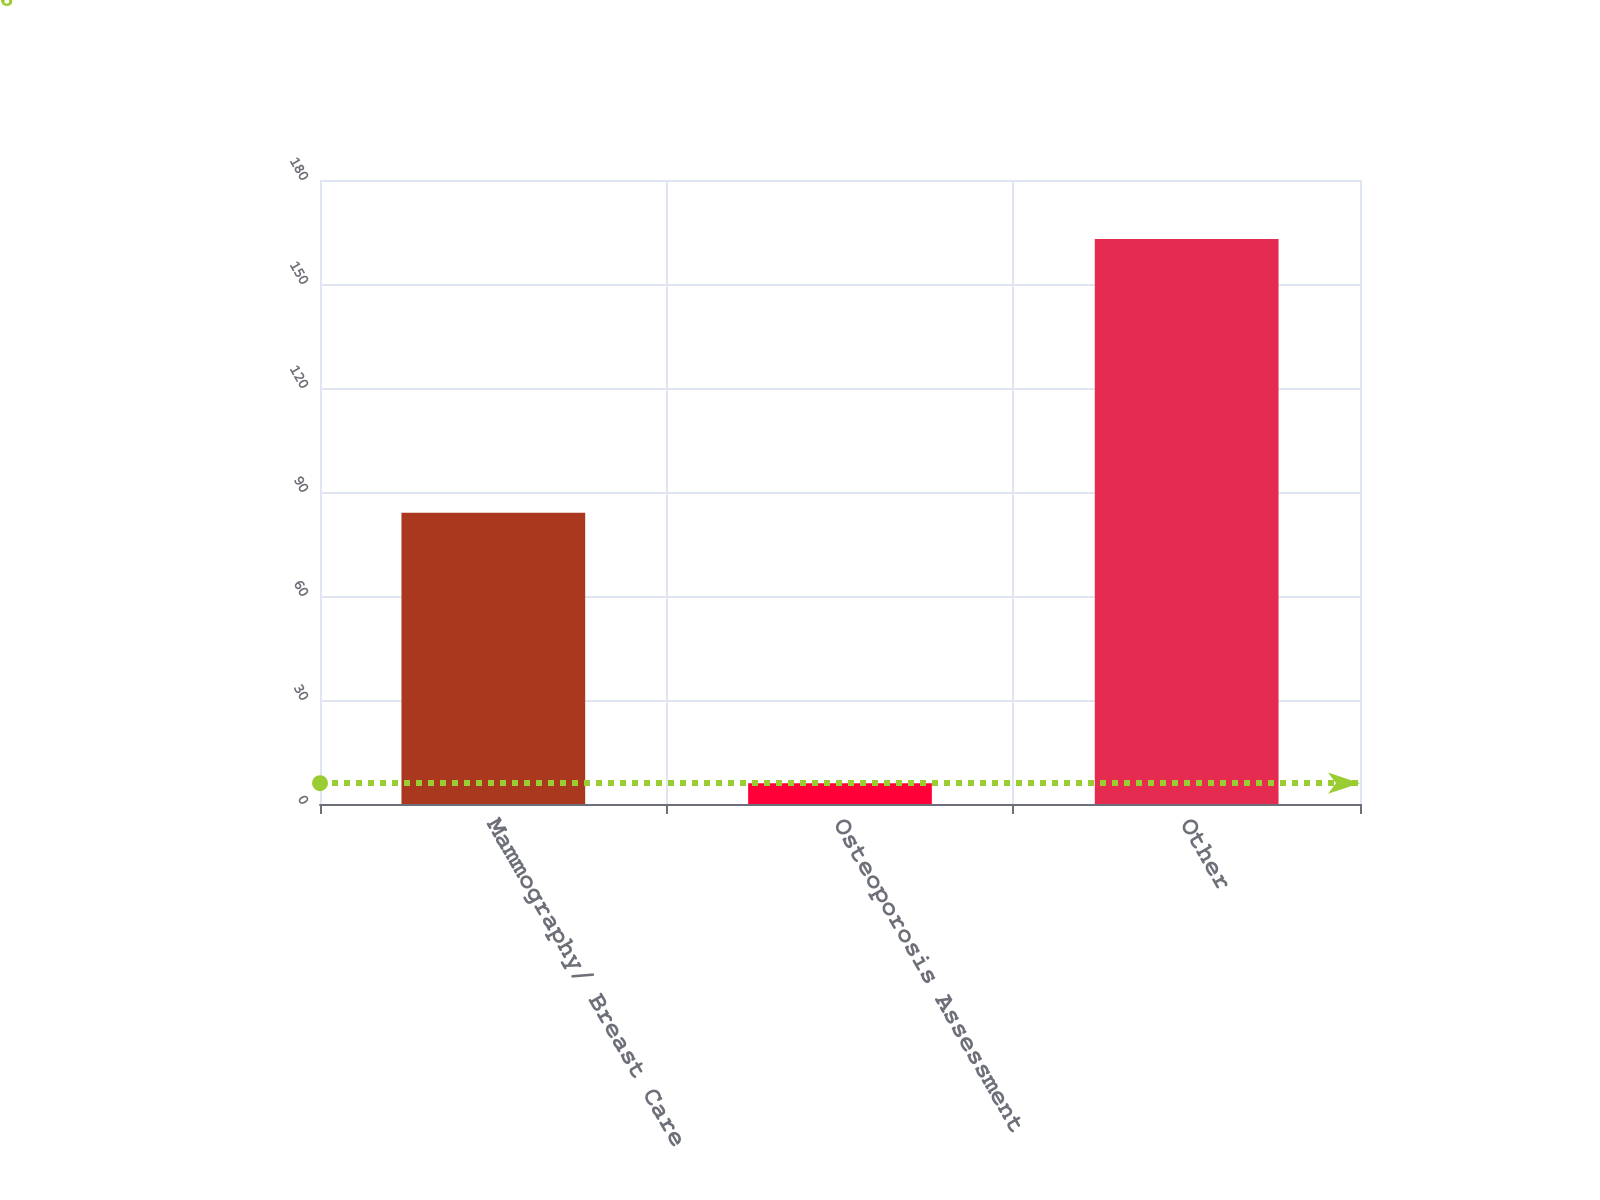<chart> <loc_0><loc_0><loc_500><loc_500><bar_chart><fcel>Mammography/ Breast Care<fcel>Osteoporosis Assessment<fcel>Other<nl><fcel>84<fcel>6<fcel>163<nl></chart> 